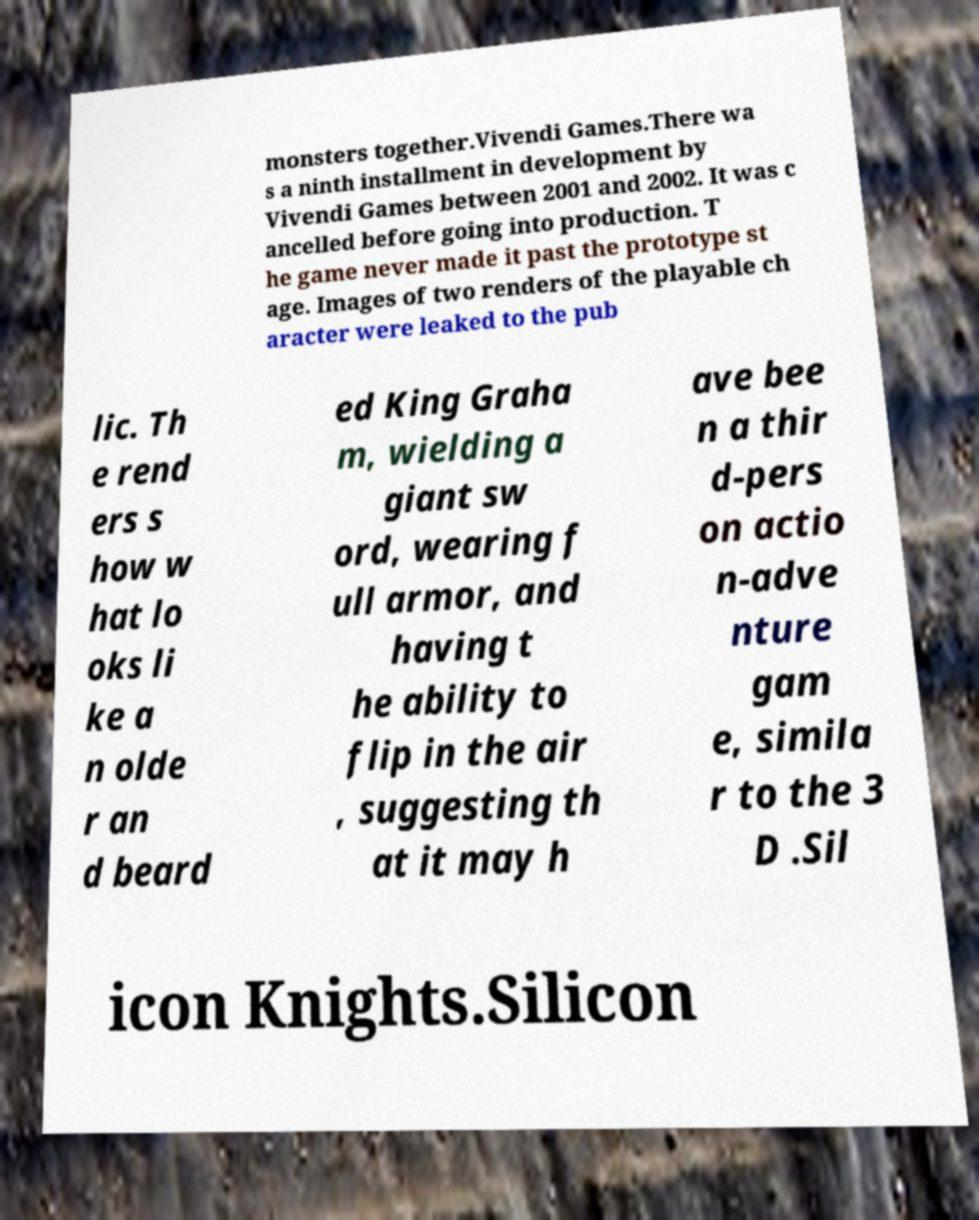I need the written content from this picture converted into text. Can you do that? monsters together.Vivendi Games.There wa s a ninth installment in development by Vivendi Games between 2001 and 2002. It was c ancelled before going into production. T he game never made it past the prototype st age. Images of two renders of the playable ch aracter were leaked to the pub lic. Th e rend ers s how w hat lo oks li ke a n olde r an d beard ed King Graha m, wielding a giant sw ord, wearing f ull armor, and having t he ability to flip in the air , suggesting th at it may h ave bee n a thir d-pers on actio n-adve nture gam e, simila r to the 3 D .Sil icon Knights.Silicon 